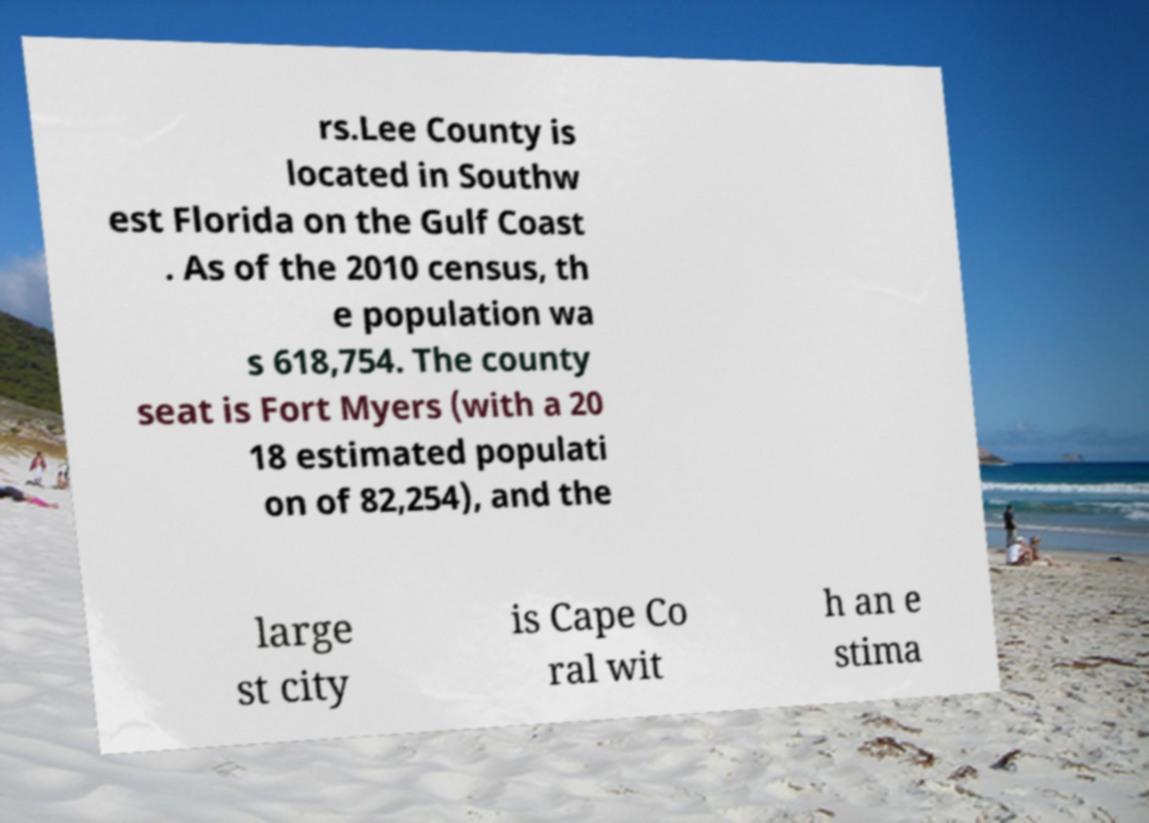What messages or text are displayed in this image? I need them in a readable, typed format. rs.Lee County is located in Southw est Florida on the Gulf Coast . As of the 2010 census, th e population wa s 618,754. The county seat is Fort Myers (with a 20 18 estimated populati on of 82,254), and the large st city is Cape Co ral wit h an e stima 